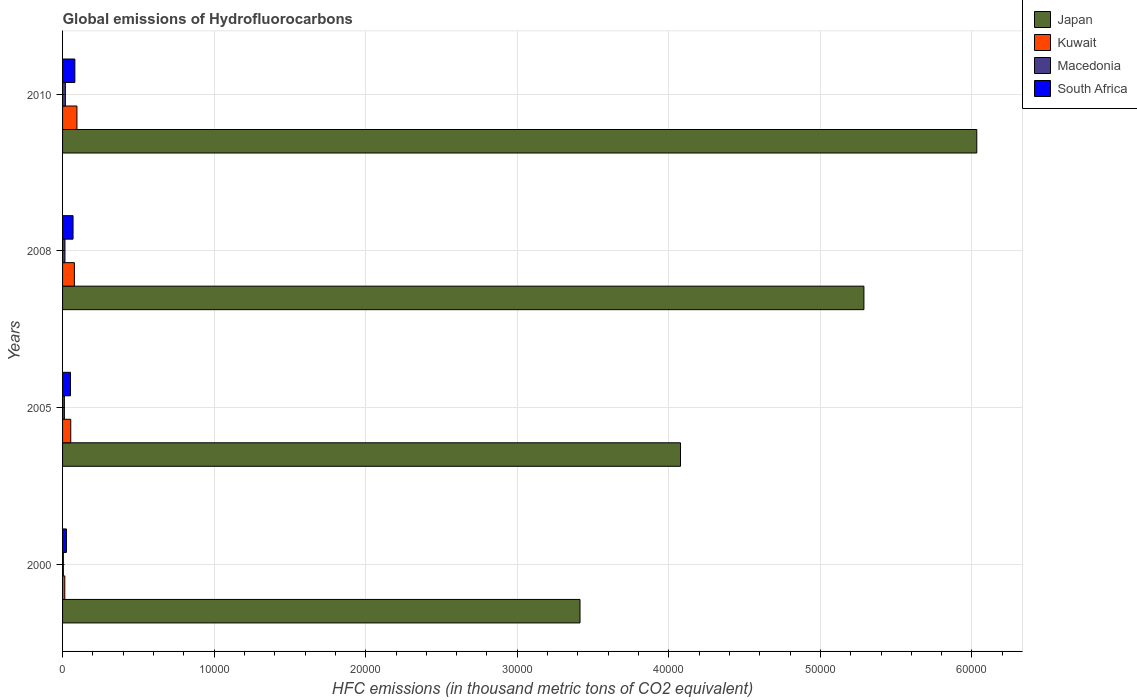How many groups of bars are there?
Provide a succinct answer. 4. Are the number of bars on each tick of the Y-axis equal?
Your response must be concise. Yes. How many bars are there on the 2nd tick from the bottom?
Your answer should be compact. 4. What is the label of the 4th group of bars from the top?
Offer a very short reply. 2000. What is the global emissions of Hydrofluorocarbons in Kuwait in 2008?
Your answer should be compact. 779. Across all years, what is the maximum global emissions of Hydrofluorocarbons in Japan?
Your answer should be compact. 6.03e+04. Across all years, what is the minimum global emissions of Hydrofluorocarbons in Macedonia?
Ensure brevity in your answer.  51.8. In which year was the global emissions of Hydrofluorocarbons in Macedonia maximum?
Provide a short and direct response. 2010. In which year was the global emissions of Hydrofluorocarbons in Macedonia minimum?
Offer a terse response. 2000. What is the total global emissions of Hydrofluorocarbons in South Africa in the graph?
Provide a succinct answer. 2281.7. What is the difference between the global emissions of Hydrofluorocarbons in Macedonia in 2000 and that in 2005?
Offer a very short reply. -67.3. What is the difference between the global emissions of Hydrofluorocarbons in Macedonia in 2005 and the global emissions of Hydrofluorocarbons in Kuwait in 2000?
Your answer should be very brief. -28.2. What is the average global emissions of Hydrofluorocarbons in Macedonia per year?
Keep it short and to the point. 128.38. In the year 2008, what is the difference between the global emissions of Hydrofluorocarbons in Japan and global emissions of Hydrofluorocarbons in Kuwait?
Your answer should be very brief. 5.21e+04. What is the ratio of the global emissions of Hydrofluorocarbons in South Africa in 2008 to that in 2010?
Provide a short and direct response. 0.85. Is the global emissions of Hydrofluorocarbons in Macedonia in 2008 less than that in 2010?
Make the answer very short. Yes. Is the difference between the global emissions of Hydrofluorocarbons in Japan in 2005 and 2010 greater than the difference between the global emissions of Hydrofluorocarbons in Kuwait in 2005 and 2010?
Make the answer very short. No. What is the difference between the highest and the second highest global emissions of Hydrofluorocarbons in Kuwait?
Your response must be concise. 169. What is the difference between the highest and the lowest global emissions of Hydrofluorocarbons in Kuwait?
Your response must be concise. 800.7. Is the sum of the global emissions of Hydrofluorocarbons in Kuwait in 2008 and 2010 greater than the maximum global emissions of Hydrofluorocarbons in Japan across all years?
Make the answer very short. No. Is it the case that in every year, the sum of the global emissions of Hydrofluorocarbons in Kuwait and global emissions of Hydrofluorocarbons in Macedonia is greater than the sum of global emissions of Hydrofluorocarbons in South Africa and global emissions of Hydrofluorocarbons in Japan?
Provide a succinct answer. No. What does the 3rd bar from the top in 2005 represents?
Ensure brevity in your answer.  Kuwait. What does the 1st bar from the bottom in 2005 represents?
Your answer should be very brief. Japan. Is it the case that in every year, the sum of the global emissions of Hydrofluorocarbons in South Africa and global emissions of Hydrofluorocarbons in Kuwait is greater than the global emissions of Hydrofluorocarbons in Macedonia?
Ensure brevity in your answer.  Yes. Are all the bars in the graph horizontal?
Your answer should be very brief. Yes. What is the difference between two consecutive major ticks on the X-axis?
Your response must be concise. 10000. Are the values on the major ticks of X-axis written in scientific E-notation?
Make the answer very short. No. Does the graph contain any zero values?
Provide a short and direct response. No. Does the graph contain grids?
Offer a very short reply. Yes. How are the legend labels stacked?
Offer a very short reply. Vertical. What is the title of the graph?
Make the answer very short. Global emissions of Hydrofluorocarbons. Does "Seychelles" appear as one of the legend labels in the graph?
Your answer should be compact. No. What is the label or title of the X-axis?
Offer a very short reply. HFC emissions (in thousand metric tons of CO2 equivalent). What is the label or title of the Y-axis?
Give a very brief answer. Years. What is the HFC emissions (in thousand metric tons of CO2 equivalent) of Japan in 2000?
Provide a short and direct response. 3.41e+04. What is the HFC emissions (in thousand metric tons of CO2 equivalent) of Kuwait in 2000?
Make the answer very short. 147.3. What is the HFC emissions (in thousand metric tons of CO2 equivalent) in Macedonia in 2000?
Your answer should be very brief. 51.8. What is the HFC emissions (in thousand metric tons of CO2 equivalent) in South Africa in 2000?
Provide a short and direct response. 254.6. What is the HFC emissions (in thousand metric tons of CO2 equivalent) in Japan in 2005?
Ensure brevity in your answer.  4.08e+04. What is the HFC emissions (in thousand metric tons of CO2 equivalent) in Kuwait in 2005?
Keep it short and to the point. 539.6. What is the HFC emissions (in thousand metric tons of CO2 equivalent) in Macedonia in 2005?
Your response must be concise. 119.1. What is the HFC emissions (in thousand metric tons of CO2 equivalent) of South Africa in 2005?
Make the answer very short. 524.5. What is the HFC emissions (in thousand metric tons of CO2 equivalent) of Japan in 2008?
Provide a succinct answer. 5.29e+04. What is the HFC emissions (in thousand metric tons of CO2 equivalent) of Kuwait in 2008?
Offer a terse response. 779. What is the HFC emissions (in thousand metric tons of CO2 equivalent) of Macedonia in 2008?
Offer a terse response. 157.6. What is the HFC emissions (in thousand metric tons of CO2 equivalent) of South Africa in 2008?
Give a very brief answer. 691.6. What is the HFC emissions (in thousand metric tons of CO2 equivalent) in Japan in 2010?
Your response must be concise. 6.03e+04. What is the HFC emissions (in thousand metric tons of CO2 equivalent) of Kuwait in 2010?
Give a very brief answer. 948. What is the HFC emissions (in thousand metric tons of CO2 equivalent) of Macedonia in 2010?
Your response must be concise. 185. What is the HFC emissions (in thousand metric tons of CO2 equivalent) in South Africa in 2010?
Provide a short and direct response. 811. Across all years, what is the maximum HFC emissions (in thousand metric tons of CO2 equivalent) of Japan?
Your answer should be very brief. 6.03e+04. Across all years, what is the maximum HFC emissions (in thousand metric tons of CO2 equivalent) in Kuwait?
Keep it short and to the point. 948. Across all years, what is the maximum HFC emissions (in thousand metric tons of CO2 equivalent) in Macedonia?
Ensure brevity in your answer.  185. Across all years, what is the maximum HFC emissions (in thousand metric tons of CO2 equivalent) of South Africa?
Offer a terse response. 811. Across all years, what is the minimum HFC emissions (in thousand metric tons of CO2 equivalent) of Japan?
Ensure brevity in your answer.  3.41e+04. Across all years, what is the minimum HFC emissions (in thousand metric tons of CO2 equivalent) in Kuwait?
Provide a short and direct response. 147.3. Across all years, what is the minimum HFC emissions (in thousand metric tons of CO2 equivalent) of Macedonia?
Your answer should be compact. 51.8. Across all years, what is the minimum HFC emissions (in thousand metric tons of CO2 equivalent) in South Africa?
Offer a very short reply. 254.6. What is the total HFC emissions (in thousand metric tons of CO2 equivalent) in Japan in the graph?
Keep it short and to the point. 1.88e+05. What is the total HFC emissions (in thousand metric tons of CO2 equivalent) in Kuwait in the graph?
Offer a very short reply. 2413.9. What is the total HFC emissions (in thousand metric tons of CO2 equivalent) in Macedonia in the graph?
Offer a terse response. 513.5. What is the total HFC emissions (in thousand metric tons of CO2 equivalent) in South Africa in the graph?
Keep it short and to the point. 2281.7. What is the difference between the HFC emissions (in thousand metric tons of CO2 equivalent) of Japan in 2000 and that in 2005?
Make the answer very short. -6628.7. What is the difference between the HFC emissions (in thousand metric tons of CO2 equivalent) of Kuwait in 2000 and that in 2005?
Ensure brevity in your answer.  -392.3. What is the difference between the HFC emissions (in thousand metric tons of CO2 equivalent) in Macedonia in 2000 and that in 2005?
Your answer should be very brief. -67.3. What is the difference between the HFC emissions (in thousand metric tons of CO2 equivalent) in South Africa in 2000 and that in 2005?
Give a very brief answer. -269.9. What is the difference between the HFC emissions (in thousand metric tons of CO2 equivalent) of Japan in 2000 and that in 2008?
Offer a very short reply. -1.87e+04. What is the difference between the HFC emissions (in thousand metric tons of CO2 equivalent) in Kuwait in 2000 and that in 2008?
Offer a very short reply. -631.7. What is the difference between the HFC emissions (in thousand metric tons of CO2 equivalent) of Macedonia in 2000 and that in 2008?
Offer a very short reply. -105.8. What is the difference between the HFC emissions (in thousand metric tons of CO2 equivalent) in South Africa in 2000 and that in 2008?
Provide a short and direct response. -437. What is the difference between the HFC emissions (in thousand metric tons of CO2 equivalent) in Japan in 2000 and that in 2010?
Your response must be concise. -2.62e+04. What is the difference between the HFC emissions (in thousand metric tons of CO2 equivalent) of Kuwait in 2000 and that in 2010?
Ensure brevity in your answer.  -800.7. What is the difference between the HFC emissions (in thousand metric tons of CO2 equivalent) in Macedonia in 2000 and that in 2010?
Offer a terse response. -133.2. What is the difference between the HFC emissions (in thousand metric tons of CO2 equivalent) in South Africa in 2000 and that in 2010?
Offer a terse response. -556.4. What is the difference between the HFC emissions (in thousand metric tons of CO2 equivalent) in Japan in 2005 and that in 2008?
Provide a succinct answer. -1.21e+04. What is the difference between the HFC emissions (in thousand metric tons of CO2 equivalent) of Kuwait in 2005 and that in 2008?
Offer a terse response. -239.4. What is the difference between the HFC emissions (in thousand metric tons of CO2 equivalent) in Macedonia in 2005 and that in 2008?
Your response must be concise. -38.5. What is the difference between the HFC emissions (in thousand metric tons of CO2 equivalent) of South Africa in 2005 and that in 2008?
Provide a short and direct response. -167.1. What is the difference between the HFC emissions (in thousand metric tons of CO2 equivalent) in Japan in 2005 and that in 2010?
Your response must be concise. -1.95e+04. What is the difference between the HFC emissions (in thousand metric tons of CO2 equivalent) of Kuwait in 2005 and that in 2010?
Your response must be concise. -408.4. What is the difference between the HFC emissions (in thousand metric tons of CO2 equivalent) in Macedonia in 2005 and that in 2010?
Make the answer very short. -65.9. What is the difference between the HFC emissions (in thousand metric tons of CO2 equivalent) of South Africa in 2005 and that in 2010?
Your response must be concise. -286.5. What is the difference between the HFC emissions (in thousand metric tons of CO2 equivalent) of Japan in 2008 and that in 2010?
Offer a very short reply. -7446.1. What is the difference between the HFC emissions (in thousand metric tons of CO2 equivalent) of Kuwait in 2008 and that in 2010?
Offer a terse response. -169. What is the difference between the HFC emissions (in thousand metric tons of CO2 equivalent) in Macedonia in 2008 and that in 2010?
Give a very brief answer. -27.4. What is the difference between the HFC emissions (in thousand metric tons of CO2 equivalent) of South Africa in 2008 and that in 2010?
Keep it short and to the point. -119.4. What is the difference between the HFC emissions (in thousand metric tons of CO2 equivalent) of Japan in 2000 and the HFC emissions (in thousand metric tons of CO2 equivalent) of Kuwait in 2005?
Your answer should be very brief. 3.36e+04. What is the difference between the HFC emissions (in thousand metric tons of CO2 equivalent) of Japan in 2000 and the HFC emissions (in thousand metric tons of CO2 equivalent) of Macedonia in 2005?
Offer a very short reply. 3.40e+04. What is the difference between the HFC emissions (in thousand metric tons of CO2 equivalent) of Japan in 2000 and the HFC emissions (in thousand metric tons of CO2 equivalent) of South Africa in 2005?
Keep it short and to the point. 3.36e+04. What is the difference between the HFC emissions (in thousand metric tons of CO2 equivalent) in Kuwait in 2000 and the HFC emissions (in thousand metric tons of CO2 equivalent) in Macedonia in 2005?
Give a very brief answer. 28.2. What is the difference between the HFC emissions (in thousand metric tons of CO2 equivalent) in Kuwait in 2000 and the HFC emissions (in thousand metric tons of CO2 equivalent) in South Africa in 2005?
Offer a very short reply. -377.2. What is the difference between the HFC emissions (in thousand metric tons of CO2 equivalent) of Macedonia in 2000 and the HFC emissions (in thousand metric tons of CO2 equivalent) of South Africa in 2005?
Ensure brevity in your answer.  -472.7. What is the difference between the HFC emissions (in thousand metric tons of CO2 equivalent) in Japan in 2000 and the HFC emissions (in thousand metric tons of CO2 equivalent) in Kuwait in 2008?
Offer a terse response. 3.34e+04. What is the difference between the HFC emissions (in thousand metric tons of CO2 equivalent) in Japan in 2000 and the HFC emissions (in thousand metric tons of CO2 equivalent) in Macedonia in 2008?
Offer a terse response. 3.40e+04. What is the difference between the HFC emissions (in thousand metric tons of CO2 equivalent) in Japan in 2000 and the HFC emissions (in thousand metric tons of CO2 equivalent) in South Africa in 2008?
Your answer should be compact. 3.34e+04. What is the difference between the HFC emissions (in thousand metric tons of CO2 equivalent) of Kuwait in 2000 and the HFC emissions (in thousand metric tons of CO2 equivalent) of Macedonia in 2008?
Offer a very short reply. -10.3. What is the difference between the HFC emissions (in thousand metric tons of CO2 equivalent) in Kuwait in 2000 and the HFC emissions (in thousand metric tons of CO2 equivalent) in South Africa in 2008?
Keep it short and to the point. -544.3. What is the difference between the HFC emissions (in thousand metric tons of CO2 equivalent) in Macedonia in 2000 and the HFC emissions (in thousand metric tons of CO2 equivalent) in South Africa in 2008?
Your answer should be compact. -639.8. What is the difference between the HFC emissions (in thousand metric tons of CO2 equivalent) of Japan in 2000 and the HFC emissions (in thousand metric tons of CO2 equivalent) of Kuwait in 2010?
Provide a succinct answer. 3.32e+04. What is the difference between the HFC emissions (in thousand metric tons of CO2 equivalent) in Japan in 2000 and the HFC emissions (in thousand metric tons of CO2 equivalent) in Macedonia in 2010?
Your answer should be compact. 3.40e+04. What is the difference between the HFC emissions (in thousand metric tons of CO2 equivalent) in Japan in 2000 and the HFC emissions (in thousand metric tons of CO2 equivalent) in South Africa in 2010?
Offer a very short reply. 3.33e+04. What is the difference between the HFC emissions (in thousand metric tons of CO2 equivalent) of Kuwait in 2000 and the HFC emissions (in thousand metric tons of CO2 equivalent) of Macedonia in 2010?
Ensure brevity in your answer.  -37.7. What is the difference between the HFC emissions (in thousand metric tons of CO2 equivalent) in Kuwait in 2000 and the HFC emissions (in thousand metric tons of CO2 equivalent) in South Africa in 2010?
Make the answer very short. -663.7. What is the difference between the HFC emissions (in thousand metric tons of CO2 equivalent) in Macedonia in 2000 and the HFC emissions (in thousand metric tons of CO2 equivalent) in South Africa in 2010?
Your response must be concise. -759.2. What is the difference between the HFC emissions (in thousand metric tons of CO2 equivalent) in Japan in 2005 and the HFC emissions (in thousand metric tons of CO2 equivalent) in Kuwait in 2008?
Give a very brief answer. 4.00e+04. What is the difference between the HFC emissions (in thousand metric tons of CO2 equivalent) in Japan in 2005 and the HFC emissions (in thousand metric tons of CO2 equivalent) in Macedonia in 2008?
Ensure brevity in your answer.  4.06e+04. What is the difference between the HFC emissions (in thousand metric tons of CO2 equivalent) in Japan in 2005 and the HFC emissions (in thousand metric tons of CO2 equivalent) in South Africa in 2008?
Make the answer very short. 4.01e+04. What is the difference between the HFC emissions (in thousand metric tons of CO2 equivalent) of Kuwait in 2005 and the HFC emissions (in thousand metric tons of CO2 equivalent) of Macedonia in 2008?
Your response must be concise. 382. What is the difference between the HFC emissions (in thousand metric tons of CO2 equivalent) of Kuwait in 2005 and the HFC emissions (in thousand metric tons of CO2 equivalent) of South Africa in 2008?
Keep it short and to the point. -152. What is the difference between the HFC emissions (in thousand metric tons of CO2 equivalent) of Macedonia in 2005 and the HFC emissions (in thousand metric tons of CO2 equivalent) of South Africa in 2008?
Make the answer very short. -572.5. What is the difference between the HFC emissions (in thousand metric tons of CO2 equivalent) of Japan in 2005 and the HFC emissions (in thousand metric tons of CO2 equivalent) of Kuwait in 2010?
Offer a terse response. 3.98e+04. What is the difference between the HFC emissions (in thousand metric tons of CO2 equivalent) in Japan in 2005 and the HFC emissions (in thousand metric tons of CO2 equivalent) in Macedonia in 2010?
Your answer should be very brief. 4.06e+04. What is the difference between the HFC emissions (in thousand metric tons of CO2 equivalent) of Japan in 2005 and the HFC emissions (in thousand metric tons of CO2 equivalent) of South Africa in 2010?
Offer a terse response. 4.00e+04. What is the difference between the HFC emissions (in thousand metric tons of CO2 equivalent) in Kuwait in 2005 and the HFC emissions (in thousand metric tons of CO2 equivalent) in Macedonia in 2010?
Your answer should be very brief. 354.6. What is the difference between the HFC emissions (in thousand metric tons of CO2 equivalent) in Kuwait in 2005 and the HFC emissions (in thousand metric tons of CO2 equivalent) in South Africa in 2010?
Provide a short and direct response. -271.4. What is the difference between the HFC emissions (in thousand metric tons of CO2 equivalent) of Macedonia in 2005 and the HFC emissions (in thousand metric tons of CO2 equivalent) of South Africa in 2010?
Keep it short and to the point. -691.9. What is the difference between the HFC emissions (in thousand metric tons of CO2 equivalent) in Japan in 2008 and the HFC emissions (in thousand metric tons of CO2 equivalent) in Kuwait in 2010?
Make the answer very short. 5.19e+04. What is the difference between the HFC emissions (in thousand metric tons of CO2 equivalent) of Japan in 2008 and the HFC emissions (in thousand metric tons of CO2 equivalent) of Macedonia in 2010?
Offer a terse response. 5.27e+04. What is the difference between the HFC emissions (in thousand metric tons of CO2 equivalent) in Japan in 2008 and the HFC emissions (in thousand metric tons of CO2 equivalent) in South Africa in 2010?
Ensure brevity in your answer.  5.21e+04. What is the difference between the HFC emissions (in thousand metric tons of CO2 equivalent) of Kuwait in 2008 and the HFC emissions (in thousand metric tons of CO2 equivalent) of Macedonia in 2010?
Offer a terse response. 594. What is the difference between the HFC emissions (in thousand metric tons of CO2 equivalent) in Kuwait in 2008 and the HFC emissions (in thousand metric tons of CO2 equivalent) in South Africa in 2010?
Offer a very short reply. -32. What is the difference between the HFC emissions (in thousand metric tons of CO2 equivalent) in Macedonia in 2008 and the HFC emissions (in thousand metric tons of CO2 equivalent) in South Africa in 2010?
Make the answer very short. -653.4. What is the average HFC emissions (in thousand metric tons of CO2 equivalent) in Japan per year?
Make the answer very short. 4.70e+04. What is the average HFC emissions (in thousand metric tons of CO2 equivalent) in Kuwait per year?
Offer a terse response. 603.48. What is the average HFC emissions (in thousand metric tons of CO2 equivalent) of Macedonia per year?
Offer a terse response. 128.38. What is the average HFC emissions (in thousand metric tons of CO2 equivalent) in South Africa per year?
Keep it short and to the point. 570.42. In the year 2000, what is the difference between the HFC emissions (in thousand metric tons of CO2 equivalent) in Japan and HFC emissions (in thousand metric tons of CO2 equivalent) in Kuwait?
Offer a terse response. 3.40e+04. In the year 2000, what is the difference between the HFC emissions (in thousand metric tons of CO2 equivalent) in Japan and HFC emissions (in thousand metric tons of CO2 equivalent) in Macedonia?
Keep it short and to the point. 3.41e+04. In the year 2000, what is the difference between the HFC emissions (in thousand metric tons of CO2 equivalent) of Japan and HFC emissions (in thousand metric tons of CO2 equivalent) of South Africa?
Make the answer very short. 3.39e+04. In the year 2000, what is the difference between the HFC emissions (in thousand metric tons of CO2 equivalent) of Kuwait and HFC emissions (in thousand metric tons of CO2 equivalent) of Macedonia?
Your response must be concise. 95.5. In the year 2000, what is the difference between the HFC emissions (in thousand metric tons of CO2 equivalent) of Kuwait and HFC emissions (in thousand metric tons of CO2 equivalent) of South Africa?
Provide a short and direct response. -107.3. In the year 2000, what is the difference between the HFC emissions (in thousand metric tons of CO2 equivalent) in Macedonia and HFC emissions (in thousand metric tons of CO2 equivalent) in South Africa?
Your answer should be very brief. -202.8. In the year 2005, what is the difference between the HFC emissions (in thousand metric tons of CO2 equivalent) in Japan and HFC emissions (in thousand metric tons of CO2 equivalent) in Kuwait?
Offer a very short reply. 4.02e+04. In the year 2005, what is the difference between the HFC emissions (in thousand metric tons of CO2 equivalent) in Japan and HFC emissions (in thousand metric tons of CO2 equivalent) in Macedonia?
Make the answer very short. 4.06e+04. In the year 2005, what is the difference between the HFC emissions (in thousand metric tons of CO2 equivalent) of Japan and HFC emissions (in thousand metric tons of CO2 equivalent) of South Africa?
Provide a succinct answer. 4.02e+04. In the year 2005, what is the difference between the HFC emissions (in thousand metric tons of CO2 equivalent) of Kuwait and HFC emissions (in thousand metric tons of CO2 equivalent) of Macedonia?
Offer a terse response. 420.5. In the year 2005, what is the difference between the HFC emissions (in thousand metric tons of CO2 equivalent) in Macedonia and HFC emissions (in thousand metric tons of CO2 equivalent) in South Africa?
Offer a very short reply. -405.4. In the year 2008, what is the difference between the HFC emissions (in thousand metric tons of CO2 equivalent) of Japan and HFC emissions (in thousand metric tons of CO2 equivalent) of Kuwait?
Ensure brevity in your answer.  5.21e+04. In the year 2008, what is the difference between the HFC emissions (in thousand metric tons of CO2 equivalent) of Japan and HFC emissions (in thousand metric tons of CO2 equivalent) of Macedonia?
Offer a terse response. 5.27e+04. In the year 2008, what is the difference between the HFC emissions (in thousand metric tons of CO2 equivalent) in Japan and HFC emissions (in thousand metric tons of CO2 equivalent) in South Africa?
Your response must be concise. 5.22e+04. In the year 2008, what is the difference between the HFC emissions (in thousand metric tons of CO2 equivalent) of Kuwait and HFC emissions (in thousand metric tons of CO2 equivalent) of Macedonia?
Ensure brevity in your answer.  621.4. In the year 2008, what is the difference between the HFC emissions (in thousand metric tons of CO2 equivalent) of Kuwait and HFC emissions (in thousand metric tons of CO2 equivalent) of South Africa?
Make the answer very short. 87.4. In the year 2008, what is the difference between the HFC emissions (in thousand metric tons of CO2 equivalent) of Macedonia and HFC emissions (in thousand metric tons of CO2 equivalent) of South Africa?
Provide a succinct answer. -534. In the year 2010, what is the difference between the HFC emissions (in thousand metric tons of CO2 equivalent) in Japan and HFC emissions (in thousand metric tons of CO2 equivalent) in Kuwait?
Your answer should be compact. 5.94e+04. In the year 2010, what is the difference between the HFC emissions (in thousand metric tons of CO2 equivalent) in Japan and HFC emissions (in thousand metric tons of CO2 equivalent) in Macedonia?
Make the answer very short. 6.01e+04. In the year 2010, what is the difference between the HFC emissions (in thousand metric tons of CO2 equivalent) of Japan and HFC emissions (in thousand metric tons of CO2 equivalent) of South Africa?
Your answer should be compact. 5.95e+04. In the year 2010, what is the difference between the HFC emissions (in thousand metric tons of CO2 equivalent) in Kuwait and HFC emissions (in thousand metric tons of CO2 equivalent) in Macedonia?
Offer a very short reply. 763. In the year 2010, what is the difference between the HFC emissions (in thousand metric tons of CO2 equivalent) in Kuwait and HFC emissions (in thousand metric tons of CO2 equivalent) in South Africa?
Give a very brief answer. 137. In the year 2010, what is the difference between the HFC emissions (in thousand metric tons of CO2 equivalent) of Macedonia and HFC emissions (in thousand metric tons of CO2 equivalent) of South Africa?
Keep it short and to the point. -626. What is the ratio of the HFC emissions (in thousand metric tons of CO2 equivalent) in Japan in 2000 to that in 2005?
Offer a terse response. 0.84. What is the ratio of the HFC emissions (in thousand metric tons of CO2 equivalent) of Kuwait in 2000 to that in 2005?
Give a very brief answer. 0.27. What is the ratio of the HFC emissions (in thousand metric tons of CO2 equivalent) of Macedonia in 2000 to that in 2005?
Keep it short and to the point. 0.43. What is the ratio of the HFC emissions (in thousand metric tons of CO2 equivalent) in South Africa in 2000 to that in 2005?
Offer a very short reply. 0.49. What is the ratio of the HFC emissions (in thousand metric tons of CO2 equivalent) of Japan in 2000 to that in 2008?
Your answer should be compact. 0.65. What is the ratio of the HFC emissions (in thousand metric tons of CO2 equivalent) in Kuwait in 2000 to that in 2008?
Provide a short and direct response. 0.19. What is the ratio of the HFC emissions (in thousand metric tons of CO2 equivalent) in Macedonia in 2000 to that in 2008?
Make the answer very short. 0.33. What is the ratio of the HFC emissions (in thousand metric tons of CO2 equivalent) in South Africa in 2000 to that in 2008?
Provide a short and direct response. 0.37. What is the ratio of the HFC emissions (in thousand metric tons of CO2 equivalent) of Japan in 2000 to that in 2010?
Give a very brief answer. 0.57. What is the ratio of the HFC emissions (in thousand metric tons of CO2 equivalent) of Kuwait in 2000 to that in 2010?
Offer a very short reply. 0.16. What is the ratio of the HFC emissions (in thousand metric tons of CO2 equivalent) of Macedonia in 2000 to that in 2010?
Provide a succinct answer. 0.28. What is the ratio of the HFC emissions (in thousand metric tons of CO2 equivalent) in South Africa in 2000 to that in 2010?
Offer a very short reply. 0.31. What is the ratio of the HFC emissions (in thousand metric tons of CO2 equivalent) of Japan in 2005 to that in 2008?
Ensure brevity in your answer.  0.77. What is the ratio of the HFC emissions (in thousand metric tons of CO2 equivalent) in Kuwait in 2005 to that in 2008?
Ensure brevity in your answer.  0.69. What is the ratio of the HFC emissions (in thousand metric tons of CO2 equivalent) of Macedonia in 2005 to that in 2008?
Provide a short and direct response. 0.76. What is the ratio of the HFC emissions (in thousand metric tons of CO2 equivalent) in South Africa in 2005 to that in 2008?
Give a very brief answer. 0.76. What is the ratio of the HFC emissions (in thousand metric tons of CO2 equivalent) in Japan in 2005 to that in 2010?
Offer a terse response. 0.68. What is the ratio of the HFC emissions (in thousand metric tons of CO2 equivalent) in Kuwait in 2005 to that in 2010?
Provide a short and direct response. 0.57. What is the ratio of the HFC emissions (in thousand metric tons of CO2 equivalent) of Macedonia in 2005 to that in 2010?
Your response must be concise. 0.64. What is the ratio of the HFC emissions (in thousand metric tons of CO2 equivalent) of South Africa in 2005 to that in 2010?
Offer a very short reply. 0.65. What is the ratio of the HFC emissions (in thousand metric tons of CO2 equivalent) in Japan in 2008 to that in 2010?
Make the answer very short. 0.88. What is the ratio of the HFC emissions (in thousand metric tons of CO2 equivalent) in Kuwait in 2008 to that in 2010?
Keep it short and to the point. 0.82. What is the ratio of the HFC emissions (in thousand metric tons of CO2 equivalent) of Macedonia in 2008 to that in 2010?
Your answer should be compact. 0.85. What is the ratio of the HFC emissions (in thousand metric tons of CO2 equivalent) of South Africa in 2008 to that in 2010?
Your response must be concise. 0.85. What is the difference between the highest and the second highest HFC emissions (in thousand metric tons of CO2 equivalent) of Japan?
Make the answer very short. 7446.1. What is the difference between the highest and the second highest HFC emissions (in thousand metric tons of CO2 equivalent) of Kuwait?
Offer a terse response. 169. What is the difference between the highest and the second highest HFC emissions (in thousand metric tons of CO2 equivalent) in Macedonia?
Provide a short and direct response. 27.4. What is the difference between the highest and the second highest HFC emissions (in thousand metric tons of CO2 equivalent) in South Africa?
Your response must be concise. 119.4. What is the difference between the highest and the lowest HFC emissions (in thousand metric tons of CO2 equivalent) of Japan?
Give a very brief answer. 2.62e+04. What is the difference between the highest and the lowest HFC emissions (in thousand metric tons of CO2 equivalent) of Kuwait?
Keep it short and to the point. 800.7. What is the difference between the highest and the lowest HFC emissions (in thousand metric tons of CO2 equivalent) in Macedonia?
Offer a terse response. 133.2. What is the difference between the highest and the lowest HFC emissions (in thousand metric tons of CO2 equivalent) of South Africa?
Offer a very short reply. 556.4. 